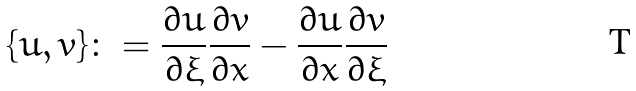<formula> <loc_0><loc_0><loc_500><loc_500>\{ u , v \} \colon = \frac { \partial u } { \partial \xi } \frac { \partial v } { \partial x } - \frac { \partial u } { \partial x } \frac { \partial v } { \partial \xi }</formula> 